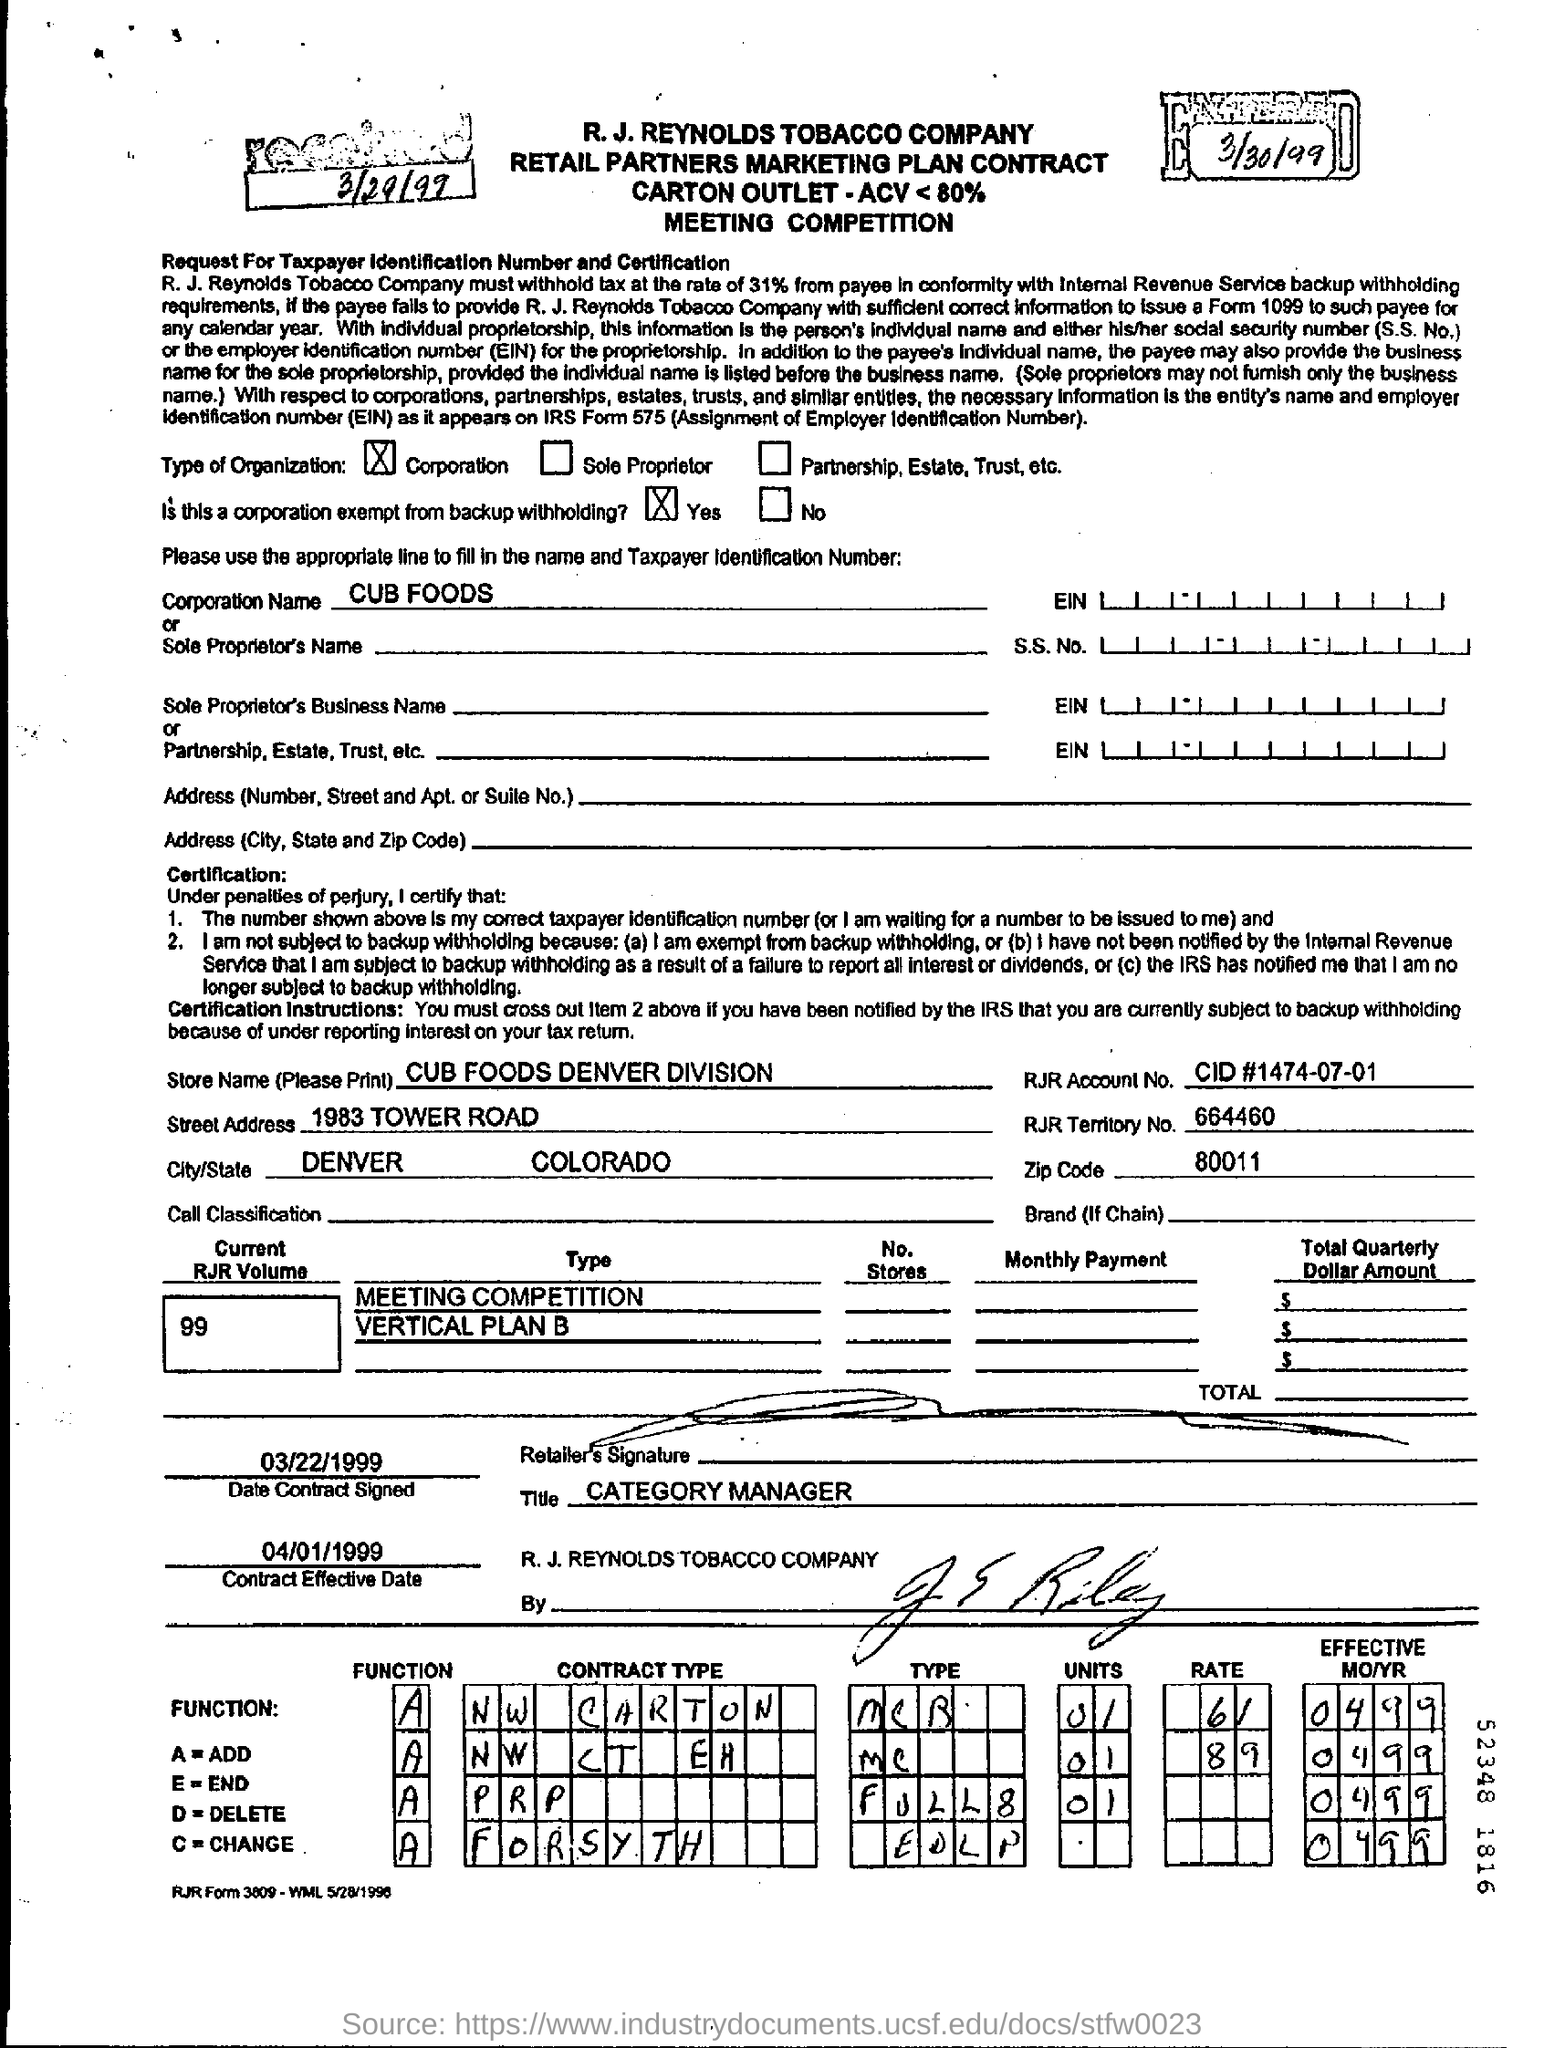Identify some key points in this picture. According to the function, A represents the result of adding two numbers. The name of the corporation is CUB FOODS. The date found at the top left corner of the document is March 29, 1999. 